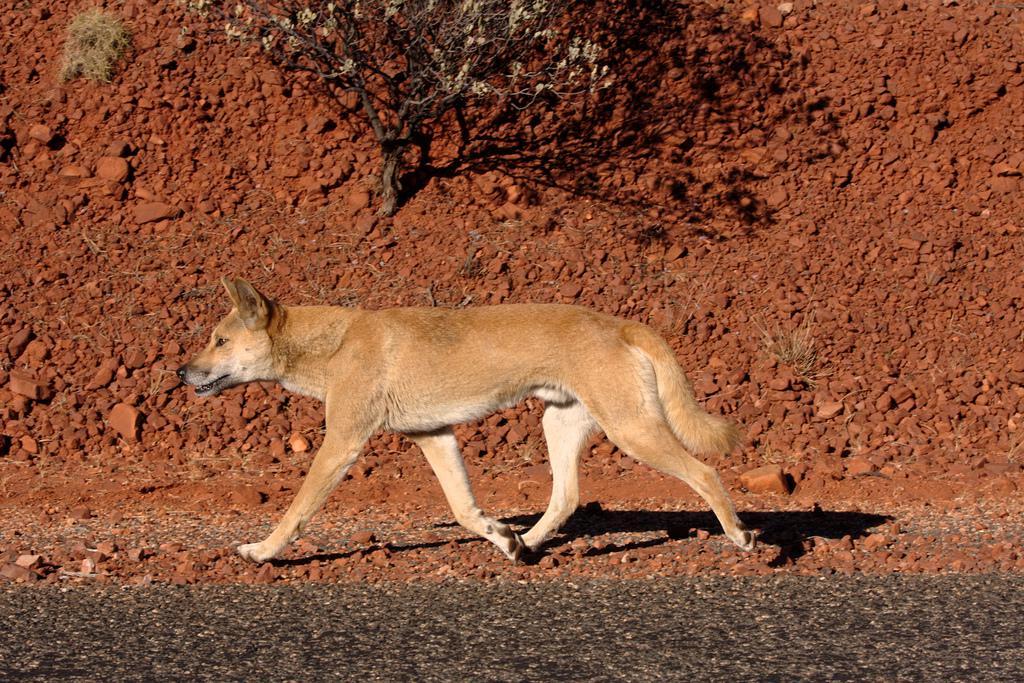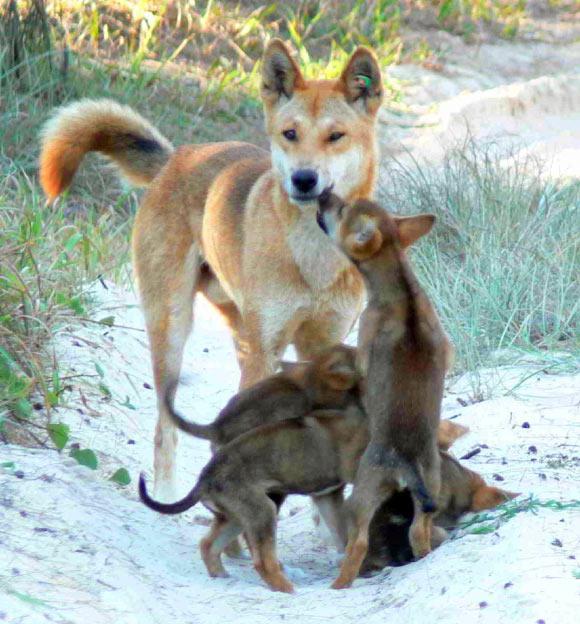The first image is the image on the left, the second image is the image on the right. Assess this claim about the two images: "An image includes an adult dingo standing by at least three juvenile dogs.". Correct or not? Answer yes or no. Yes. 